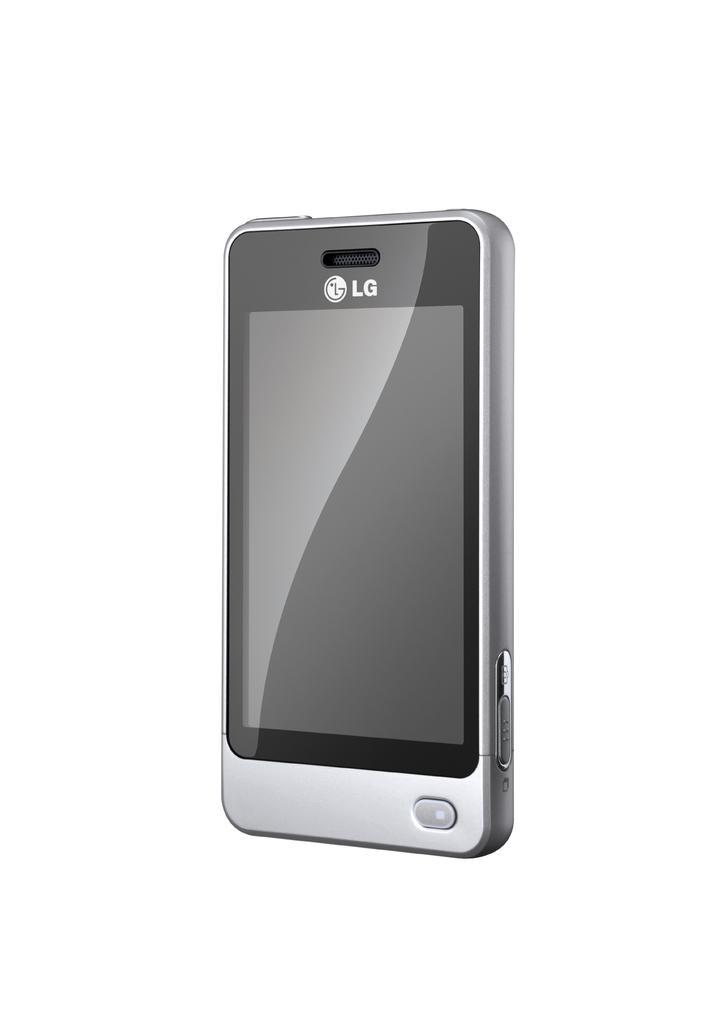How would you summarize this image in a sentence or two? In this picture I can see an electronic device in front and I can see a logo and 2 alphabets on it and I can see the buttons on the right side of this phone and I see that it is white color in the background. 